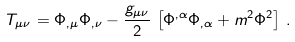Convert formula to latex. <formula><loc_0><loc_0><loc_500><loc_500>T _ { \mu \nu } = \Phi _ { , \mu } \Phi _ { , \nu } - \frac { g _ { \mu \nu } } { 2 } \, \left [ \Phi ^ { , \alpha } \Phi _ { , \alpha } + m ^ { 2 } \Phi ^ { 2 } \right ] \, .</formula> 